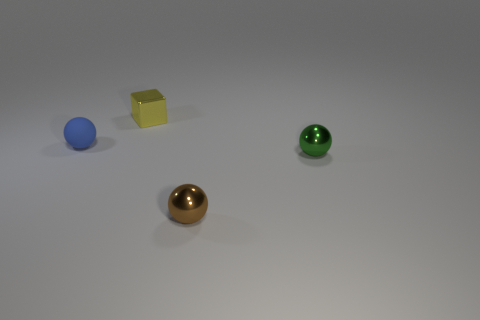Add 3 gray spheres. How many objects exist? 7 Subtract all balls. How many objects are left? 1 Subtract all tiny purple matte blocks. Subtract all tiny blue objects. How many objects are left? 3 Add 1 blue matte objects. How many blue matte objects are left? 2 Add 1 brown objects. How many brown objects exist? 2 Subtract 0 cyan spheres. How many objects are left? 4 